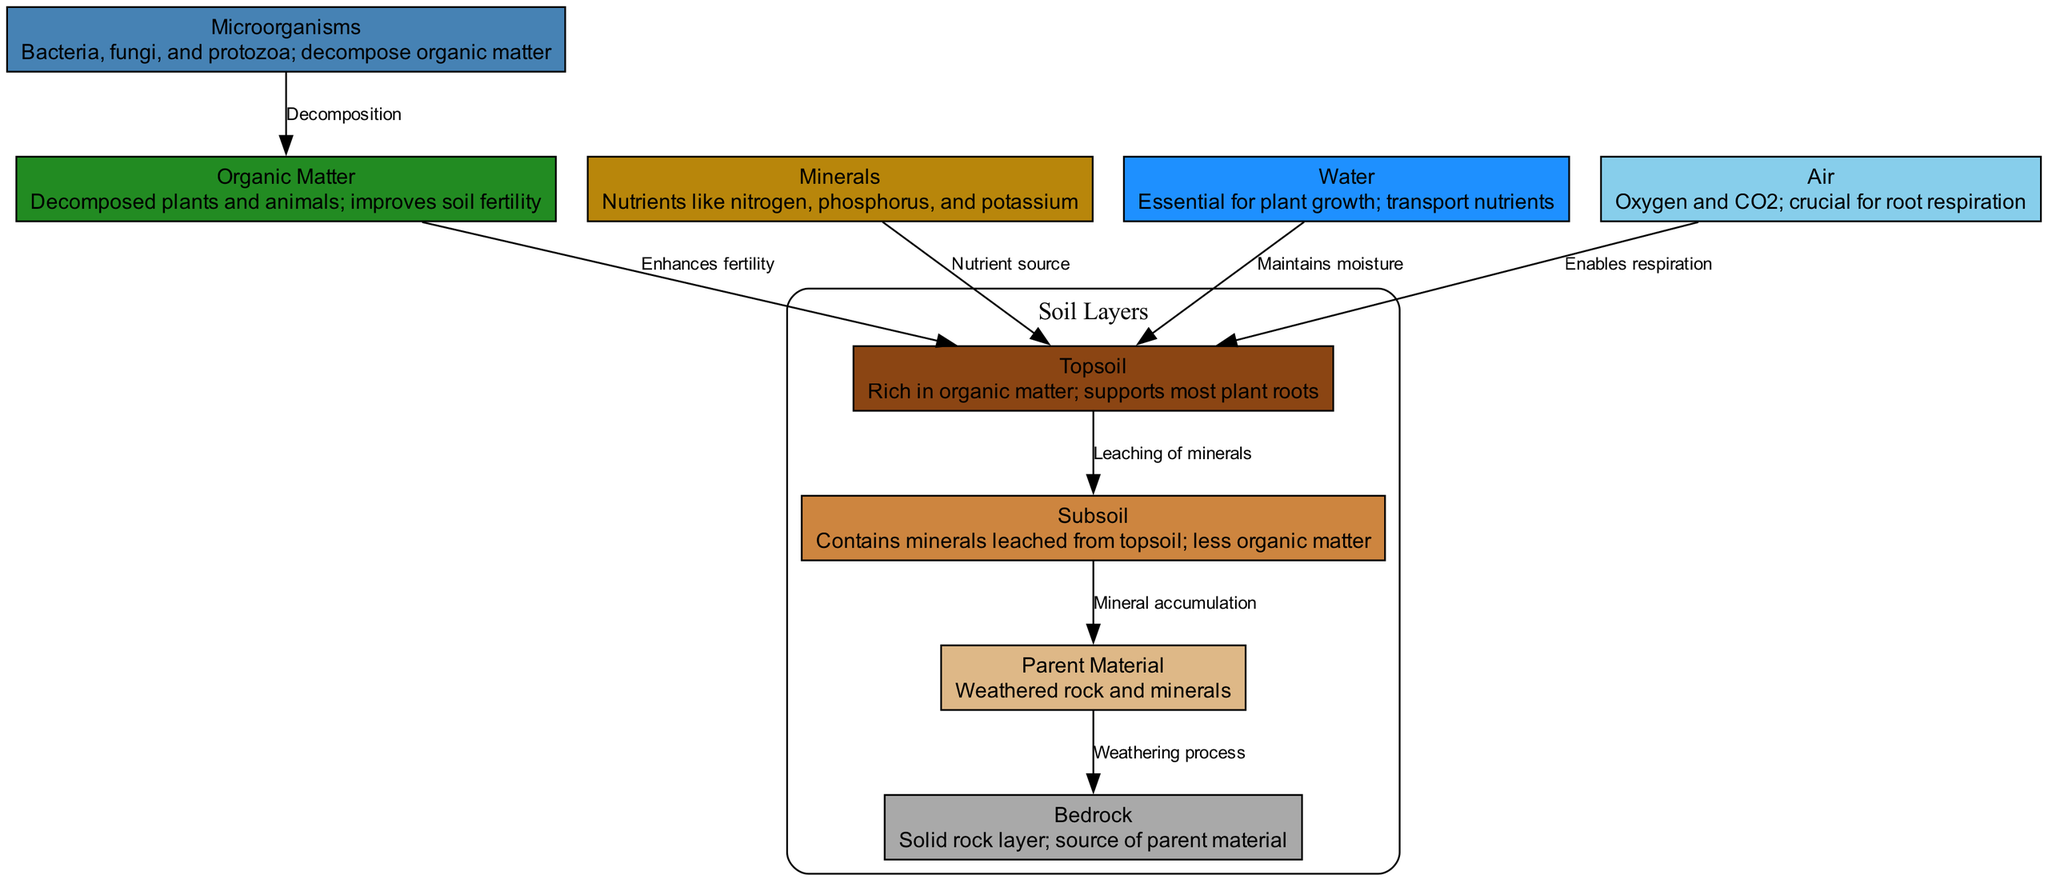What layer of soil is rich in organic matter? The diagram identifies the "Topsoil" as the layer that is rich in organic matter. The details associated with the "Topsoil" node specifically highlight that it supports most plant roots and is characterized by its organic richness.
Answer: Topsoil What supports most plant roots? The "Topsoil" layer is specifically mentioned in the diagram as the layer that supports most plant roots due to its nutrient-rich composition.
Answer: Topsoil How many types of soil layers are depicted? By inspecting the diagram, the main soil layers presented are "Topsoil," "Subsoil," "Parent Material," and "Bedrock," totaling four distinct categories.
Answer: Four What processes lead to mineral leaching? The edge connecting "Topsoil" to "Subsoil" indicates the process of "Leaching of minerals," illustrating how minerals move from the topsoil to subsoil.
Answer: Leaching of minerals Which layer consists of weathered rock and minerals? The "Parent Material" is described in the diagram as consisting of weathered rock and minerals, indicating its foundational role in soil composition.
Answer: Parent Material What is a primary nutrient source for plants, as per the diagram? The "Minerals" node is highlighted as a nutrient source, specifically mentioning essential nutrients like nitrogen, phosphorus, and potassium which are crucial for plant growth.
Answer: Minerals Which microorganisms are involved in the decomposition of organic matter? The "Microorganisms" node elaborates on bacteria, fungi, and protozoa as the key players in decomposing organic matter, enhancing soil fertility.
Answer: Microorganisms What crucial role does water play in soil composition? The "Water" node emphasizes its essential function in maintaining moisture for plant growth and helping in the transportation of nutrients, which is vital for plant health and development.
Answer: Maintains moisture How does organic matter enhance soil fertility? The relationship illustrated between "Organic Matter" and "Topsoil" indicates that organic matter decomposes to enhance fertility in the topsoil layer, providing vital nutrients for plant growth.
Answer: Enhances fertility 